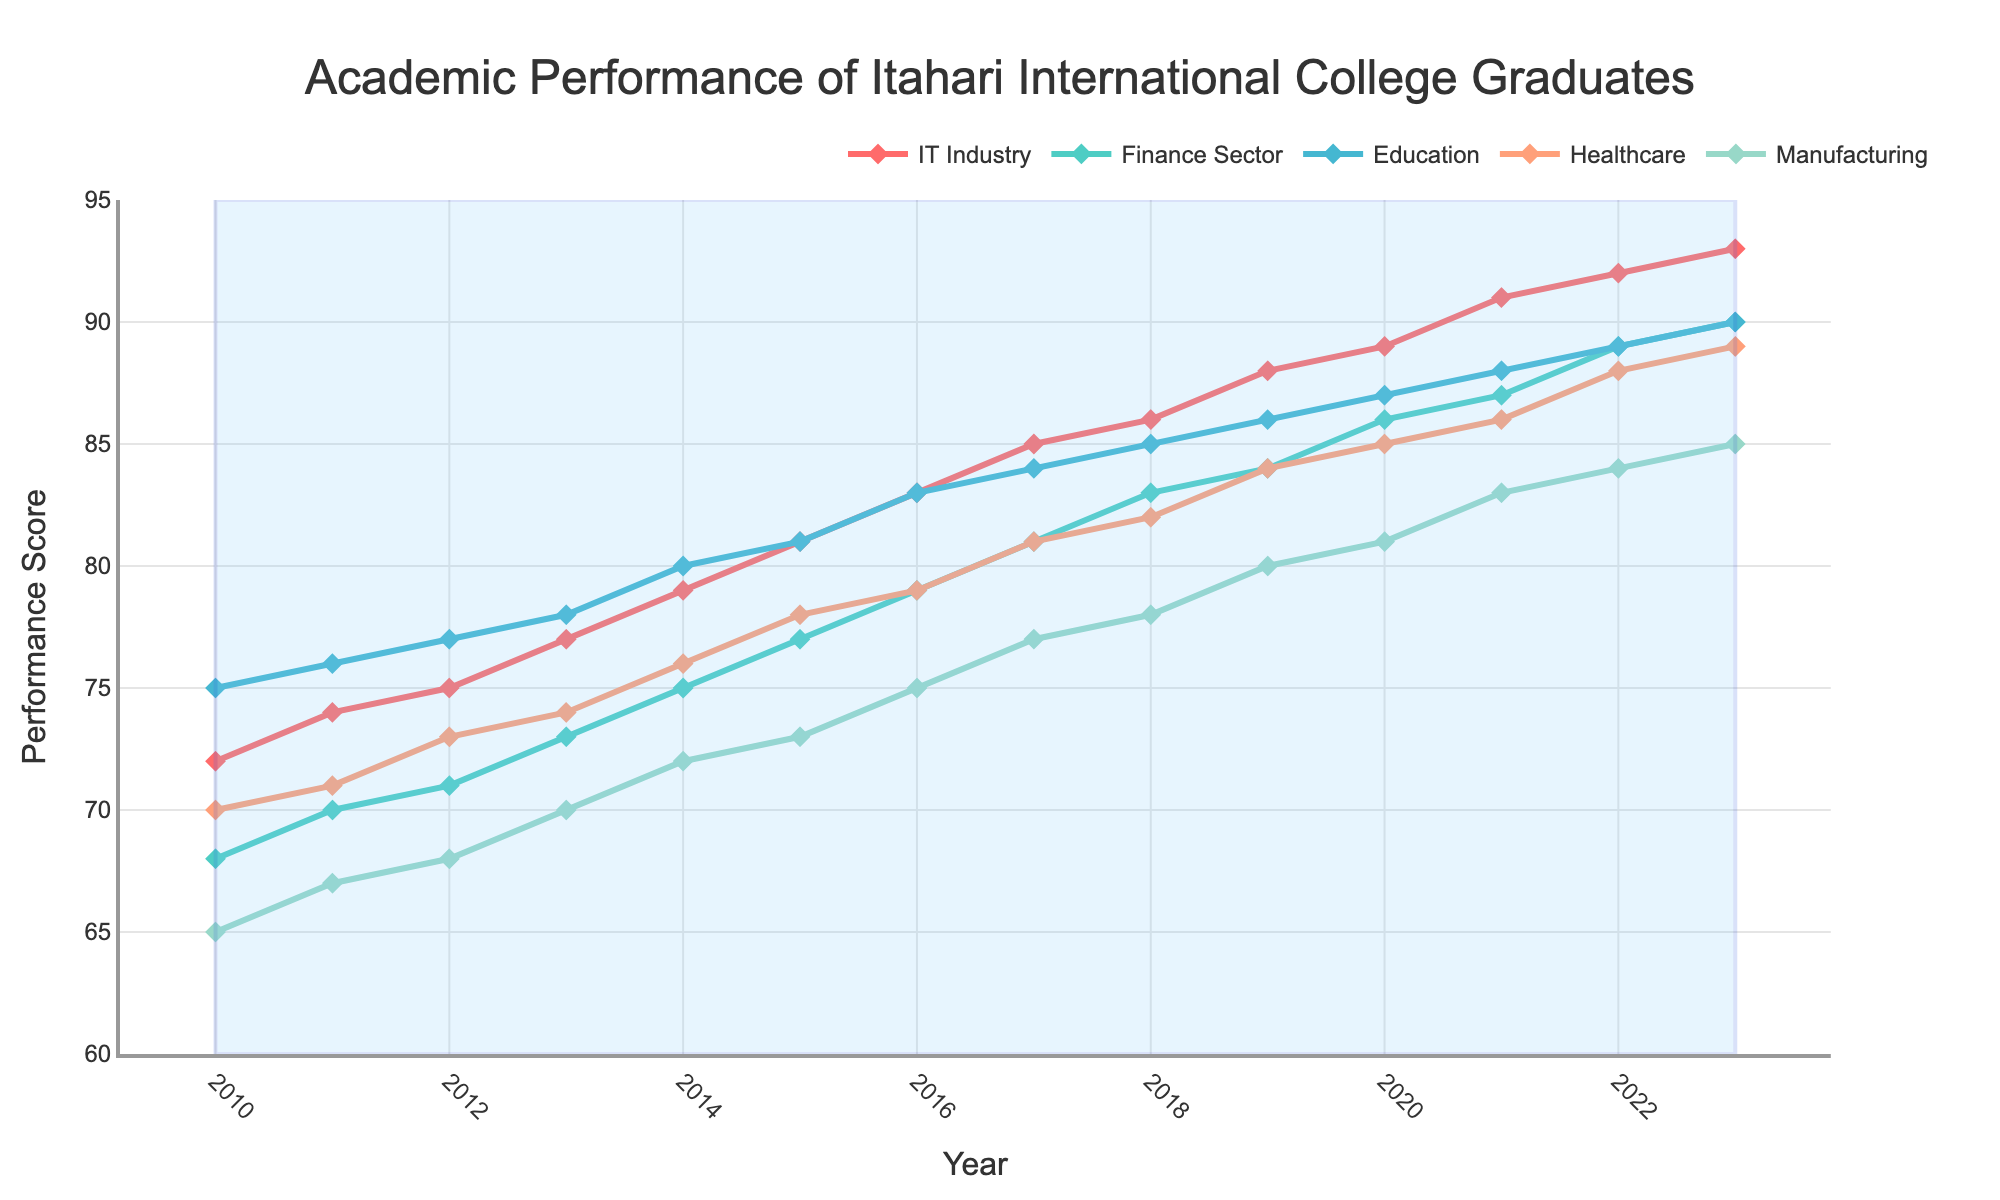What's the highest performance score achieved in the IT Industry? To find the highest performance score for the IT Industry, look for the maximum value in the IT Industry line on the chart. The highest point is at 93 in the year 2023.
Answer: 93 How did the performance in the Healthcare sector change from 2010 to 2023? To determine the change in the Healthcare sector from 2010 to 2023, compare the performance scores in these years. The score increases from 70 in 2010 to 89 in 2023. The change is 89 - 70 = 19 points.
Answer: Increased by 19 points Between 2015 and 2020, which industry saw the most improvement in performance scores? Calculate the improvement for each industry by subtracting the 2015 score from the 2020 score. IT: 89 - 81 = 8, Finance: 86 - 77 = 9, Education: 87 - 81 = 6, Healthcare: 85 - 78 = 7, Manufacturing: 81 - 73 = 8. The Finance Sector had the highest improvement of 9 points.
Answer: Finance Sector Which industry had the lowest performance score in the year 2014 and what was the score? Look at the performance scores for all industries in 2014 and identify the lowest value. Manufacturing has the lowest score at 72.
Answer: Manufacturing with 72 In which year did the Education sector surpass an 80 performance score? Find the year when the Education sector score first exceeds 80. The score is 80 in 2014, and surpassing 80 in 2015 with a score of 81.
Answer: 2015 What was the average performance score of the Finance Sector over the entire period? Calculate the average by summing all performance scores of the Finance Sector from 2010 to 2023 and divide by the number of years (14). Sum is 1156, average is 1156 / 14 = 82.57.
Answer: 82.57 Which industry consistently performed better than the others from 2010 to 2023? Analyze the trends of all industries across the given period. The IT Industry consistently has the highest scores compared to others from 2010 to 2023.
Answer: IT Industry In what year did the IT Industry and Education sector have an equal performance score, and what was that score? Find the year where the IT Industry and Education sector lines intersect. In 2010, both sectors have a performance score of 72.
Answer: 2010 with 72 How much did the Manufacturing sector's performance score increase from 2010 to 2023? Subtract the 2010 score from the 2023 score. The Manufacturing sector's performance score increased from 65 in 2010 to 85 in 2023, an increase of 85 - 65 = 20 points.
Answer: 20 points 